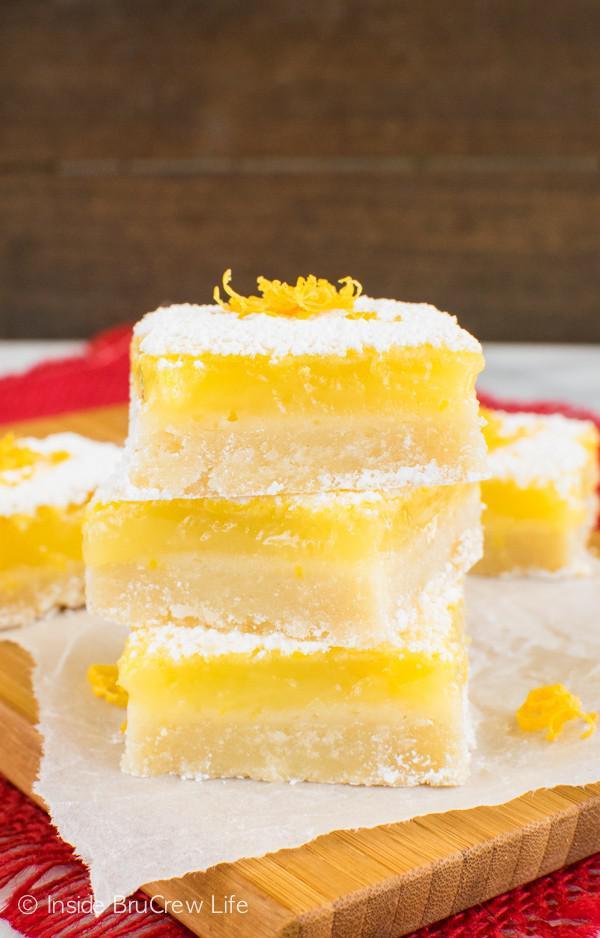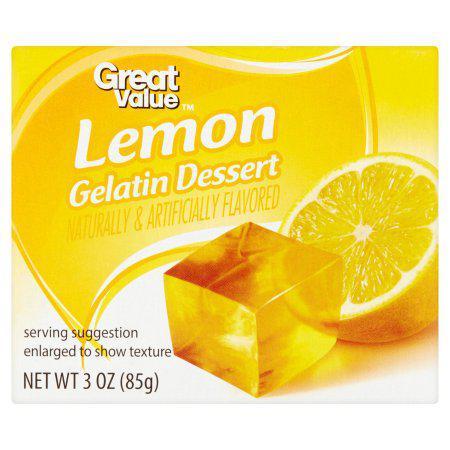The first image is the image on the left, the second image is the image on the right. For the images shown, is this caption "There are more than two whole lemons." true? Answer yes or no. No. The first image is the image on the left, the second image is the image on the right. Examine the images to the left and right. Is the description "There are at least 8 lemons." accurate? Answer yes or no. No. 